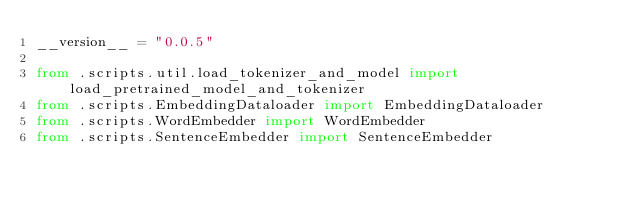Convert code to text. <code><loc_0><loc_0><loc_500><loc_500><_Python_>__version__ = "0.0.5"

from .scripts.util.load_tokenizer_and_model import load_pretrained_model_and_tokenizer
from .scripts.EmbeddingDataloader import EmbeddingDataloader
from .scripts.WordEmbedder import WordEmbedder
from .scripts.SentenceEmbedder import SentenceEmbedder</code> 